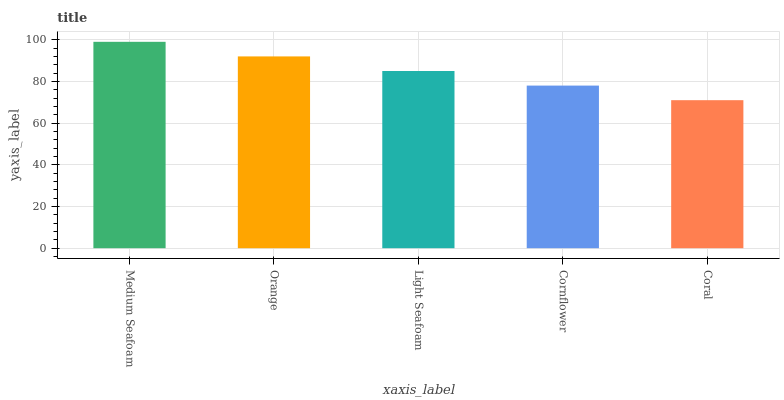Is Coral the minimum?
Answer yes or no. Yes. Is Medium Seafoam the maximum?
Answer yes or no. Yes. Is Orange the minimum?
Answer yes or no. No. Is Orange the maximum?
Answer yes or no. No. Is Medium Seafoam greater than Orange?
Answer yes or no. Yes. Is Orange less than Medium Seafoam?
Answer yes or no. Yes. Is Orange greater than Medium Seafoam?
Answer yes or no. No. Is Medium Seafoam less than Orange?
Answer yes or no. No. Is Light Seafoam the high median?
Answer yes or no. Yes. Is Light Seafoam the low median?
Answer yes or no. Yes. Is Medium Seafoam the high median?
Answer yes or no. No. Is Coral the low median?
Answer yes or no. No. 